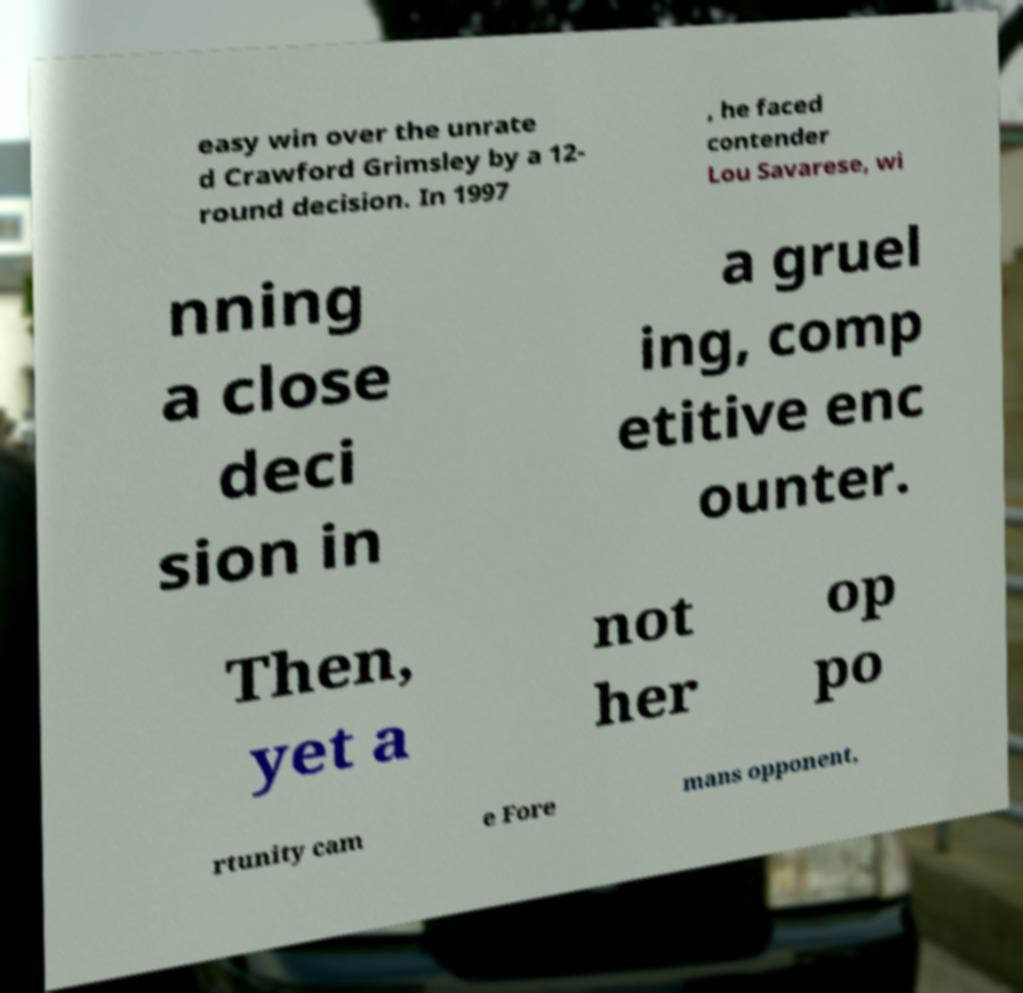For documentation purposes, I need the text within this image transcribed. Could you provide that? easy win over the unrate d Crawford Grimsley by a 12- round decision. In 1997 , he faced contender Lou Savarese, wi nning a close deci sion in a gruel ing, comp etitive enc ounter. Then, yet a not her op po rtunity cam e Fore mans opponent, 